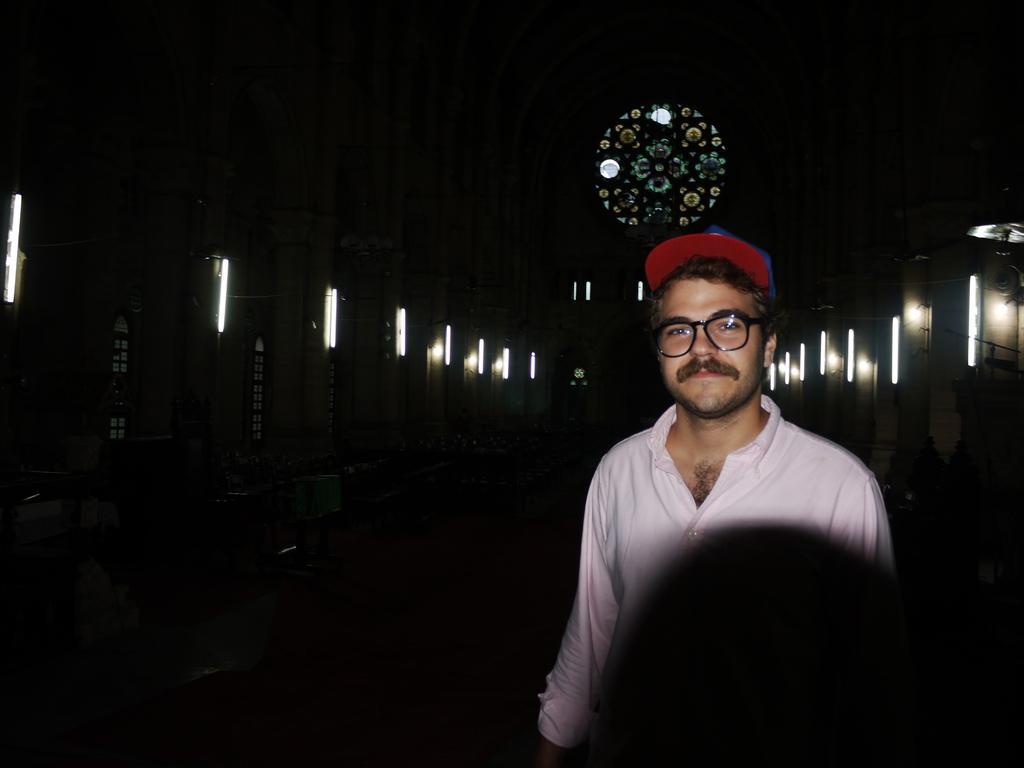In one or two sentences, can you explain what this image depicts? In this image on the right, there is a man, he wears a shirt, cap. In the background there are lights and it is dark. 